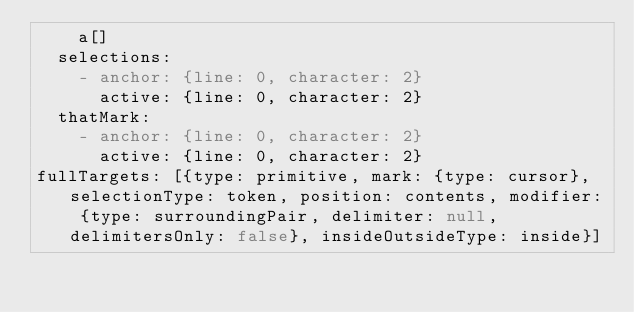<code> <loc_0><loc_0><loc_500><loc_500><_YAML_>    a[]
  selections:
    - anchor: {line: 0, character: 2}
      active: {line: 0, character: 2}
  thatMark:
    - anchor: {line: 0, character: 2}
      active: {line: 0, character: 2}
fullTargets: [{type: primitive, mark: {type: cursor}, selectionType: token, position: contents, modifier: {type: surroundingPair, delimiter: null, delimitersOnly: false}, insideOutsideType: inside}]
</code> 